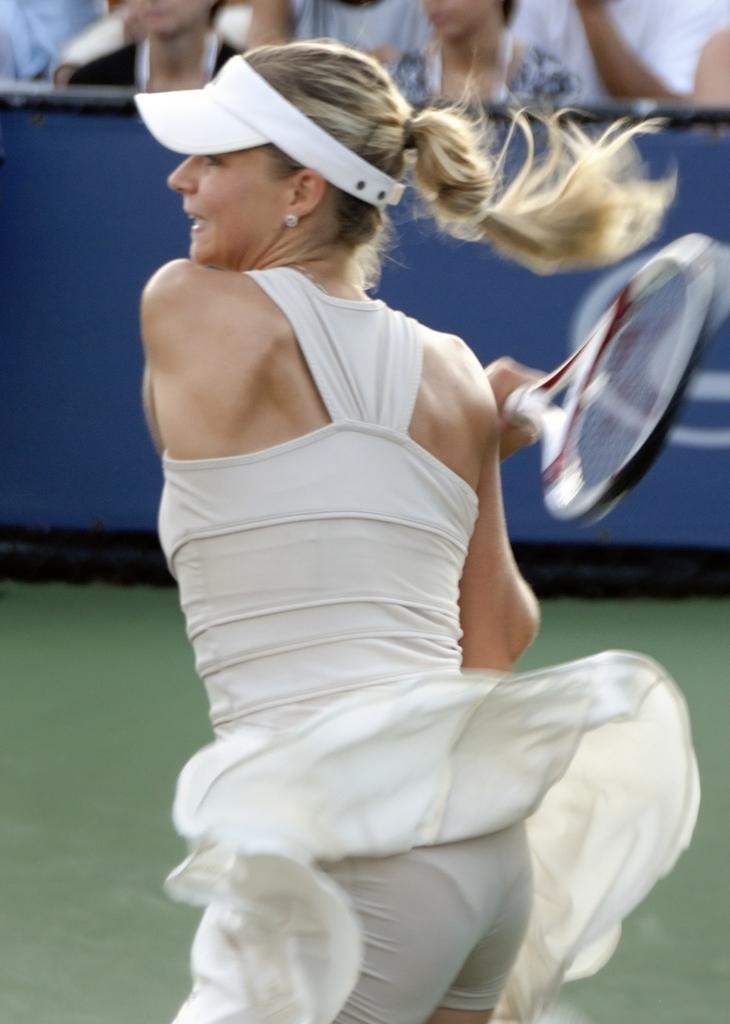Who is the main subject in the image? There is a lady in the image. What is the lady wearing? The lady is wearing a white dress. What is the lady holding in her hand? The lady is standing and holding a racket in her hand. What can be seen in the background of the image? There is a blue poster in the background, and there are people sitting in the background. What type of rock is the lady climbing in the image? There is no rock present in the image; the lady is holding a racket and standing on a flat surface. Is there a bear visible in the image? No, there is no bear present in the image. 